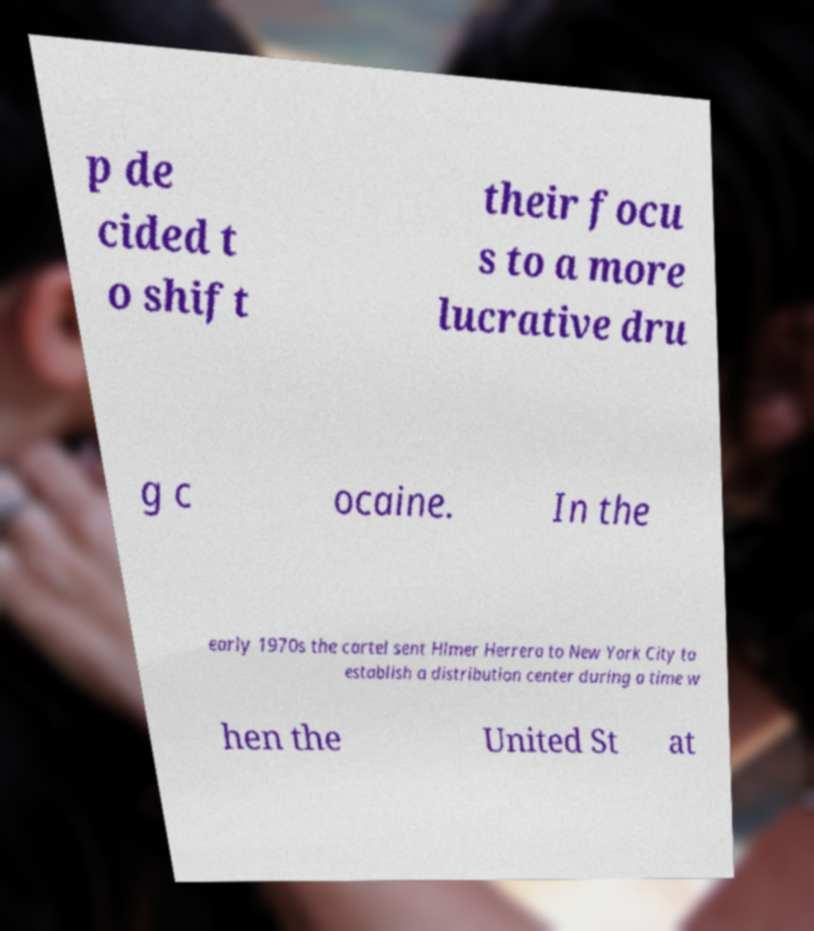I need the written content from this picture converted into text. Can you do that? p de cided t o shift their focu s to a more lucrative dru g c ocaine. In the early 1970s the cartel sent Hlmer Herrera to New York City to establish a distribution center during a time w hen the United St at 